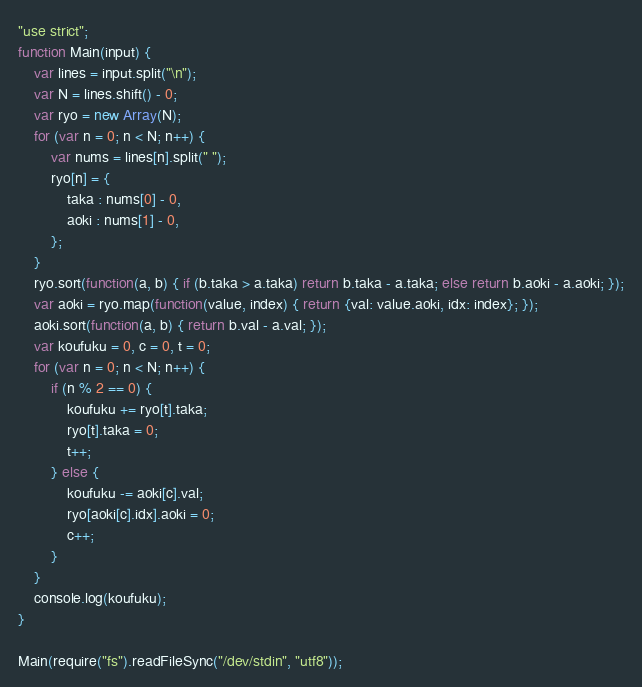<code> <loc_0><loc_0><loc_500><loc_500><_JavaScript_>"use strict";
function Main(input) {
    var lines = input.split("\n");
    var N = lines.shift() - 0;
    var ryo = new Array(N);
    for (var n = 0; n < N; n++) {
        var nums = lines[n].split(" ");
        ryo[n] = {
            taka : nums[0] - 0,
            aoki : nums[1] - 0,
        };
    }
    ryo.sort(function(a, b) { if (b.taka > a.taka) return b.taka - a.taka; else return b.aoki - a.aoki; });
    var aoki = ryo.map(function(value, index) { return {val: value.aoki, idx: index}; });
    aoki.sort(function(a, b) { return b.val - a.val; });
    var koufuku = 0, c = 0, t = 0;
    for (var n = 0; n < N; n++) {
        if (n % 2 == 0) {
            koufuku += ryo[t].taka;
            ryo[t].taka = 0;
            t++;
        } else {
            koufuku -= aoki[c].val;
            ryo[aoki[c].idx].aoki = 0;
            c++;
        }
    }
    console.log(koufuku);
}

Main(require("fs").readFileSync("/dev/stdin", "utf8"));
</code> 